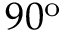Convert formula to latex. <formula><loc_0><loc_0><loc_500><loc_500>9 0 ^ { o }</formula> 